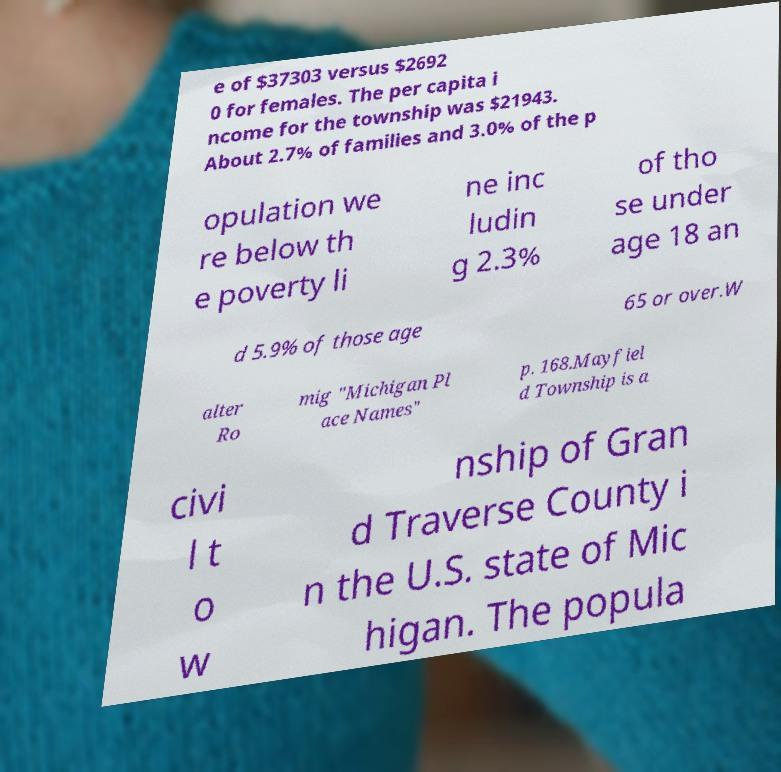Could you extract and type out the text from this image? e of $37303 versus $2692 0 for females. The per capita i ncome for the township was $21943. About 2.7% of families and 3.0% of the p opulation we re below th e poverty li ne inc ludin g 2.3% of tho se under age 18 an d 5.9% of those age 65 or over.W alter Ro mig "Michigan Pl ace Names" p. 168.Mayfiel d Township is a civi l t o w nship of Gran d Traverse County i n the U.S. state of Mic higan. The popula 